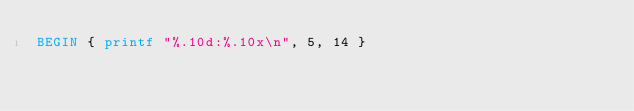Convert code to text. <code><loc_0><loc_0><loc_500><loc_500><_Awk_>BEGIN { printf "%.10d:%.10x\n", 5, 14 }
</code> 